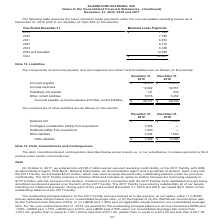According to Alarmcom Holdings's financial document, What were the accounts payable in 2019? According to the financial document, 32,878 (in thousands). The relevant text states: "ber 31, 2019 December 31, 2018 Accounts payable $ 32,878 $ 20,214 Accrued expenses 10,092 34,557 Subsidiary unit awards 141 200 Other current liabilities 5,..." Also, What were the subsidiary unit awards in 2019? According to the financial document, 141 (in thousands). The relevant text states: "ued expenses 10,092 34,557 Subsidiary unit awards 141 200 Other current liabilities 5,616 3,459 Accounts payable, accrued expenses and other current liab..." Also, What were the accrued expenses in 2018? According to the financial document, 34,557 (in thousands). The relevant text states: "payable $ 32,878 $ 20,214 Accrued expenses 10,092 34,557 Subsidiary unit awards 141 200 Other current liabilities 5,616 3,459 Accounts payable, accrued expe..." Also, can you calculate: What was the change in the Subsidiary unit awards between 2018 and 2019? Based on the calculation: 141-200, the result is -59 (in thousands). This is based on the information: "expenses 10,092 34,557 Subsidiary unit awards 141 200 Other current liabilities 5,616 3,459 Accounts payable, accrued expenses and other current liabilit ued expenses 10,092 34,557 Subsidiary unit awa..." The key data points involved are: 141, 200. Also, How many components in 2018 exceeded $10,000 thousand? Counting the relevant items in the document: Accounts payable, Accrued expenses, I find 2 instances. The key data points involved are: Accounts payable, Accrued expenses. Also, can you calculate: What was the percentage change between accounts payable in 2018 and 2019? To answer this question, I need to perform calculations using the financial data. The calculation is: (32,878-20,214)/20,214, which equals 62.65 (percentage). This is based on the information: "ber 31, 2019 December 31, 2018 Accounts payable $ 32,878 $ 20,214 Accrued expenses 10,092 34,557 Subsidiary unit awards 141 200 Other current liabilities 5, 019 December 31, 2018 Accounts payable $ 32..." The key data points involved are: 20,214, 32,878. 